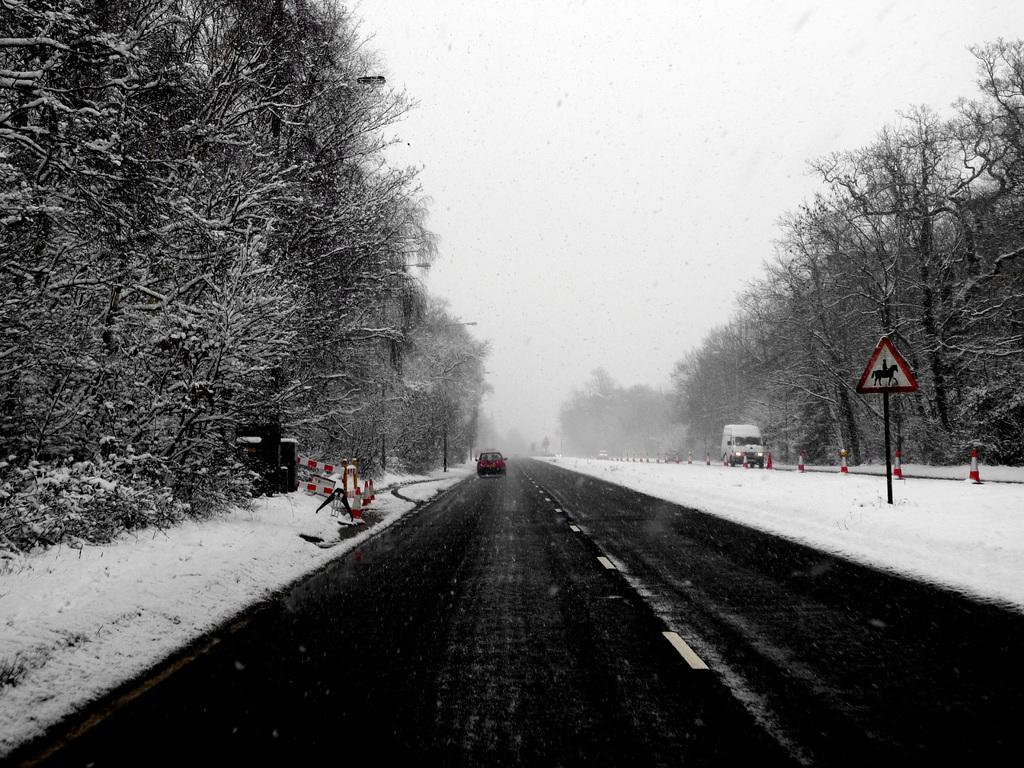How would you summarize this image in a sentence or two? In this image we can see road on which there are some vehicles moving there are some traffic cones, signage boards and there are some trees at left and right side of the image, there is snow and at the top of the image there is clear sky. 